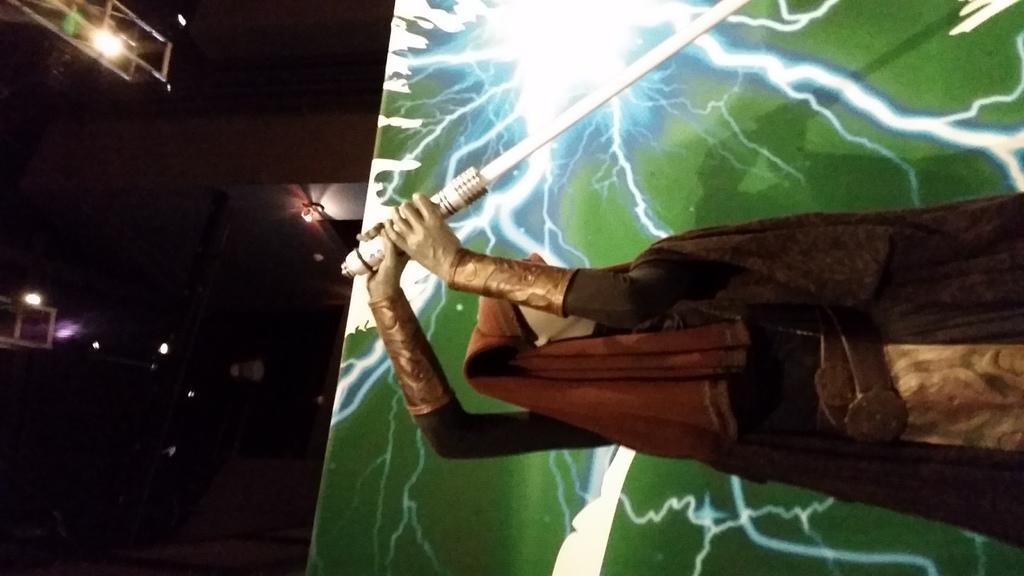What is the main subject of the image? There is a statue in the image. What is the statue holding? The statue is holding a sword. What book is the statue reading in the image? There is no book present in the image; the statue is holding a sword. 